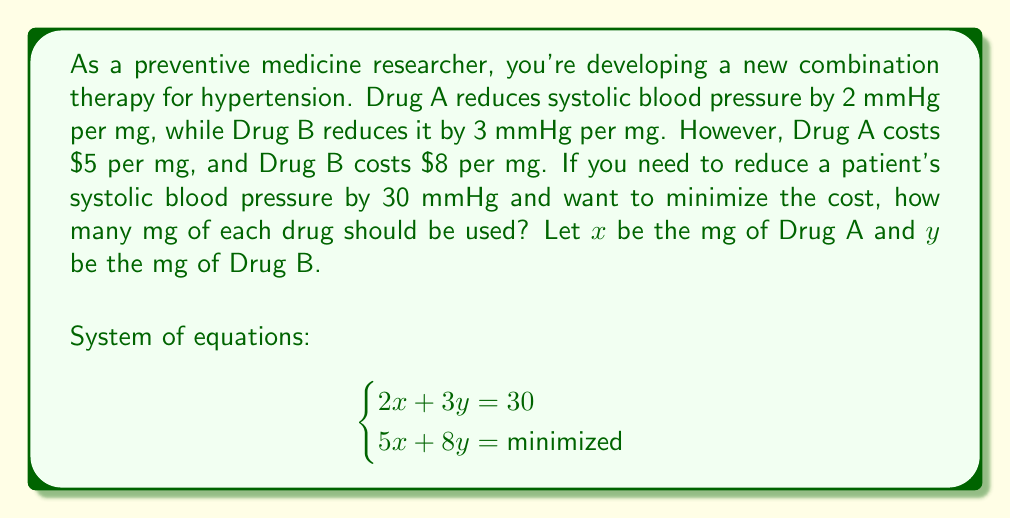Help me with this question. To solve this optimization problem, we'll use the substitution method:

1) From the first equation: $2x + 3y = 30$
   Solve for $x$: $x = 15 - \frac{3}{2}y$

2) Substitute this into the cost equation:
   $5(15 - \frac{3}{2}y) + 8y = 75 - \frac{15}{2}y + 8y = 75 + \frac{1}{2}y$

3) To minimize the cost, we want to minimize $\frac{1}{2}y$. Since $y$ represents mg of drug and can't be negative, the minimum occurs when $y = 0$.

4) If $y = 0$, then from step 1: $x = 15$

5) Verify the solution satisfies the original equation:
   $2(15) + 3(0) = 30$

Therefore, to minimize cost while reducing blood pressure by 30 mmHg, we should use 15 mg of Drug A and 0 mg of Drug B.

The minimum cost is: $5(15) + 8(0) = $75$
Answer: 15 mg of Drug A, 0 mg of Drug B 